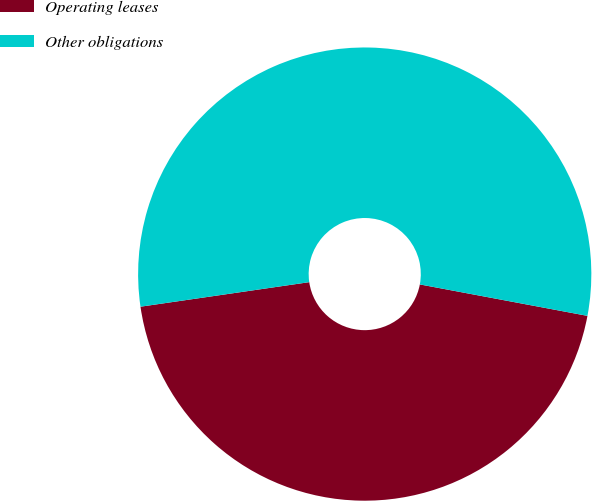Convert chart. <chart><loc_0><loc_0><loc_500><loc_500><pie_chart><fcel>Operating leases<fcel>Other obligations<nl><fcel>44.75%<fcel>55.25%<nl></chart> 